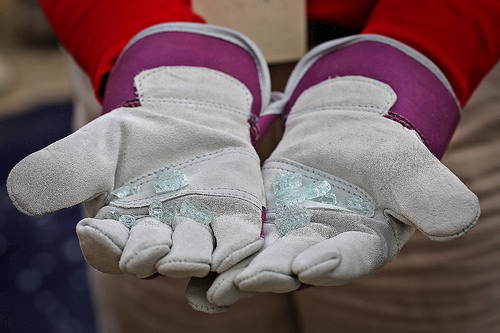<image>
Is there a glass in the glove? No. The glass is not contained within the glove. These objects have a different spatial relationship. Is there a crystals in front of the glove? No. The crystals is not in front of the glove. The spatial positioning shows a different relationship between these objects. 